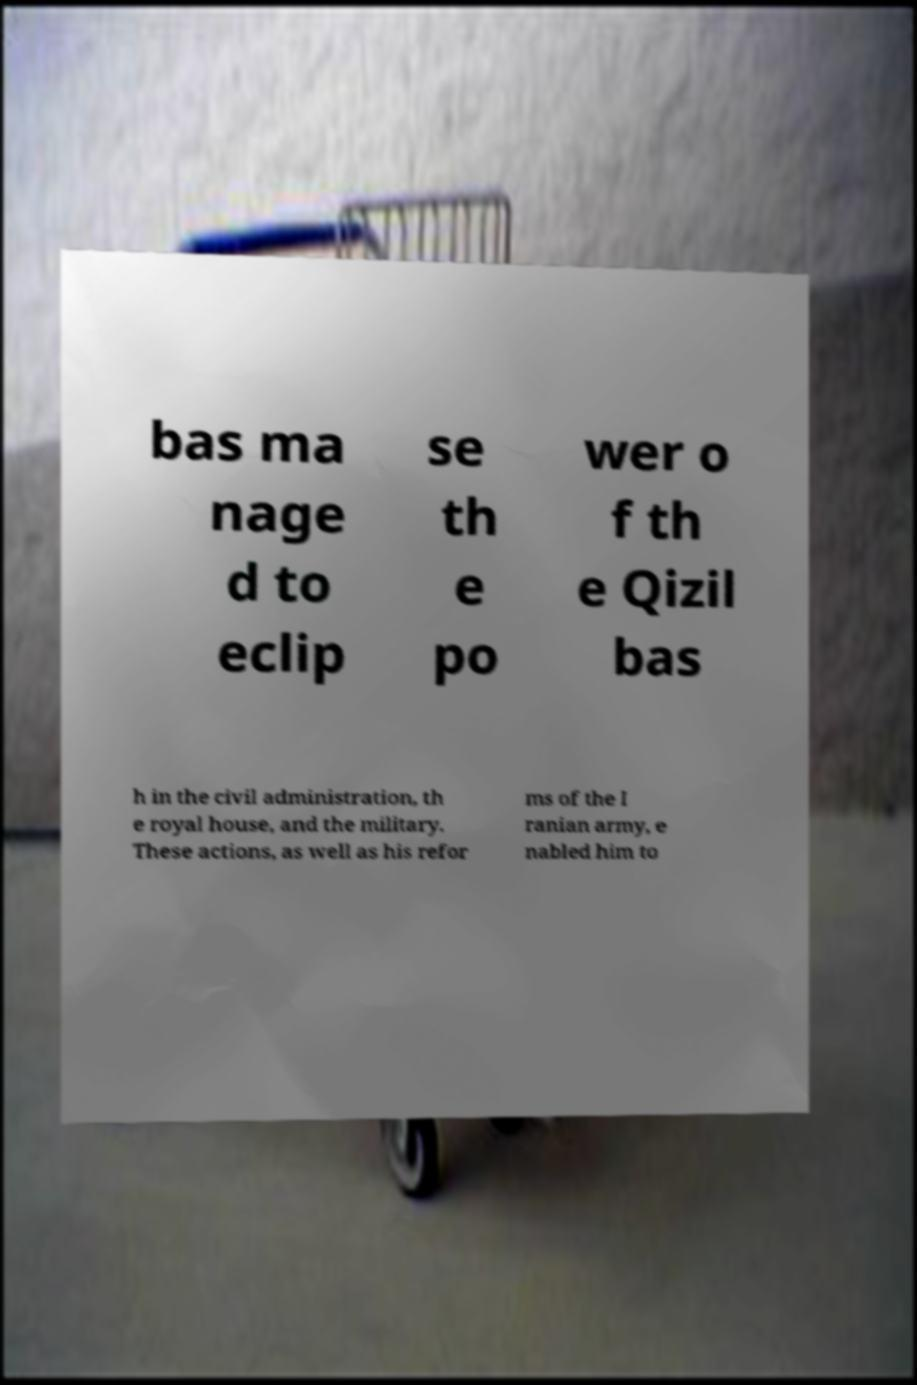I need the written content from this picture converted into text. Can you do that? bas ma nage d to eclip se th e po wer o f th e Qizil bas h in the civil administration, th e royal house, and the military. These actions, as well as his refor ms of the I ranian army, e nabled him to 